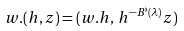<formula> <loc_0><loc_0><loc_500><loc_500>w . ( h , z ) = ( w . h , \, h ^ { - B ^ { \flat } ( \lambda ) } z )</formula> 